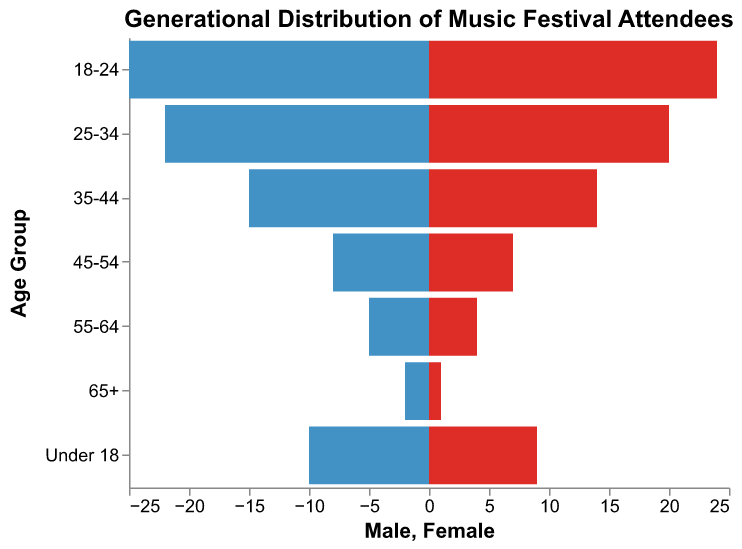What's the title of the figure? The title of the figure is displayed prominently at the top. By looking at the figure, you can see that the title is "Generational Distribution of Music Festival Attendees".
Answer: Generational Distribution of Music Festival Attendees What color represents the bars for male attendees? The bars on the left-hand side of the figure are in a shade of blue, which represents male attendees. You can visually identify the bar colors to determine this.
Answer: Blue Which age group has the highest number of female attendees? To find the age group with the highest number of female attendees, look for the longest bar on the right side of the population pyramid. The 18-24 age group has the longest bar for females.
Answer: 18-24 How many more male attendees are there than female attendees in the 25-34 age group? Look at the 25-34 age group. The number of male attendees is 22, and the number of female attendees is 20. The difference is 22 - 20 = 2.
Answer: 2 What is the total number of attendees in the 55-64 age group? Add the number of male attendees (5) and female attendees (4) in the 55-64 age group. 5 + 4 = 9
Answer: 9 In which age group is the number of male attendees less than 10? Look for age groups where the left-hand bar (representing males) is less than 10 units long. The age group 65+ fits this criterion with only 2 males.
Answer: 65+ What is the second most populous age group for overall attendees? Sum the male and female attendees for each age group and identify the second largest total. 18-24 has 25 + 24 = 49, 25-34 has 22 + 20 = 42, 35-44 has 15 + 14 = 29. The second highest after 18-24 (49) is 25-34 (42).
Answer: 25-34 Are there more attendees in the 18-24 age group than in the 35-44, 45-54, and 55-64 age groups combined? Calculate the total attendees for each group and sum them. 35-44: 15+14=29, 45-54: 8+7=15, 55-64: 5+4=9. Combined: 29 + 15 + 9 = 53. Compare with 18-24: 25 + 24 = 49. 49 is not more than 53.
Answer: No Which gender has more attendees overall? Calculate the total number of male and female attendees across all age groups. Males: 2+5+8+15+22+25+10 = 87. Females: 1+4+7+14+20+24+9 = 79. Hence, males have more attendees.
Answer: Males 